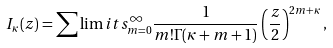<formula> <loc_0><loc_0><loc_500><loc_500>I _ { \kappa } ( z ) = \sum \lim i t s _ { m = 0 } ^ { \infty } \frac { 1 } { m ! \Gamma ( \kappa + m + 1 ) } \left ( \frac { z } { 2 } \right ) ^ { 2 m + \kappa } ,</formula> 